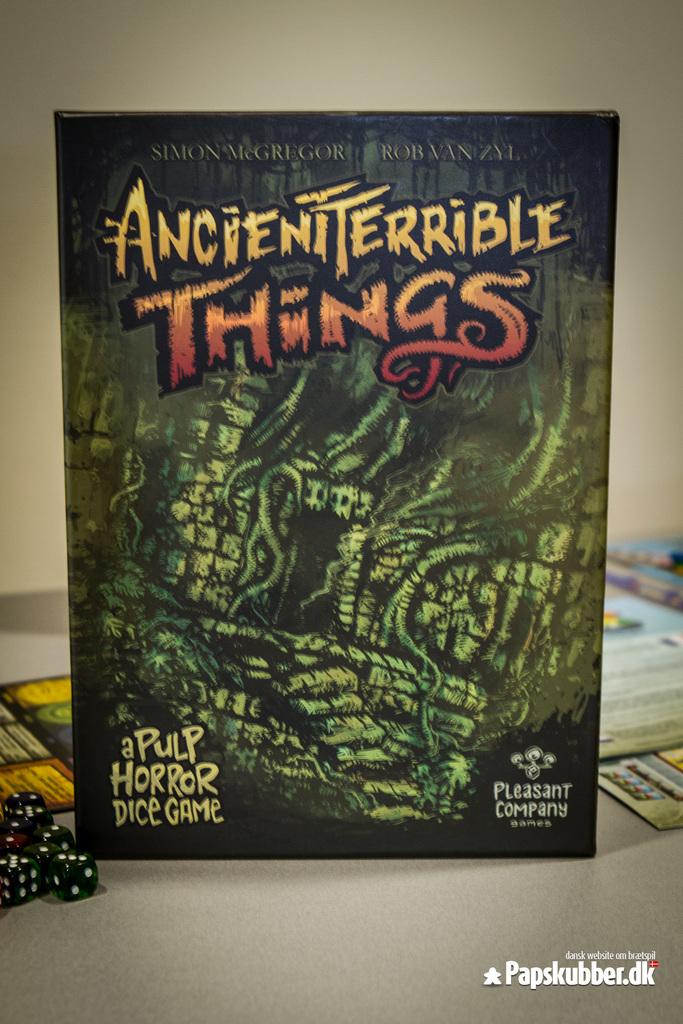What type of game is this?
Your answer should be compact. Pulp horror dice game. What is the name of the game?
Provide a short and direct response. Ancient terrible things. 